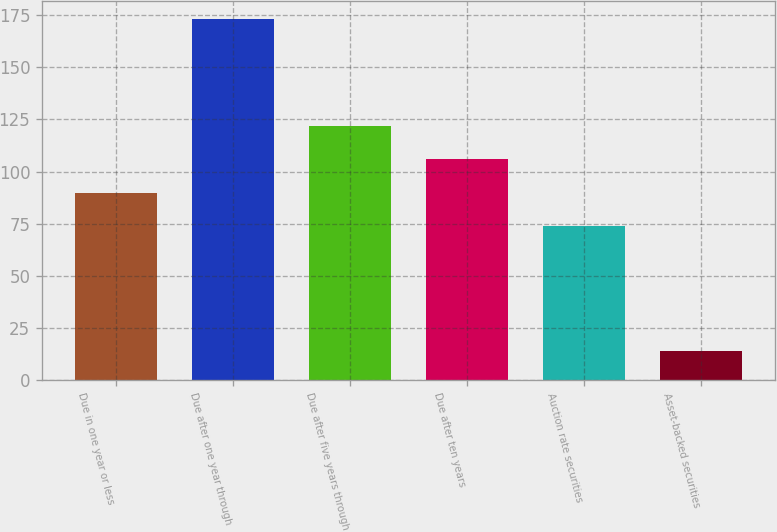Convert chart to OTSL. <chart><loc_0><loc_0><loc_500><loc_500><bar_chart><fcel>Due in one year or less<fcel>Due after one year through<fcel>Due after five years through<fcel>Due after ten years<fcel>Auction rate securities<fcel>Asset-backed securities<nl><fcel>89.9<fcel>173<fcel>121.7<fcel>105.8<fcel>74<fcel>14<nl></chart> 